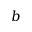Convert formula to latex. <formula><loc_0><loc_0><loc_500><loc_500>b</formula> 